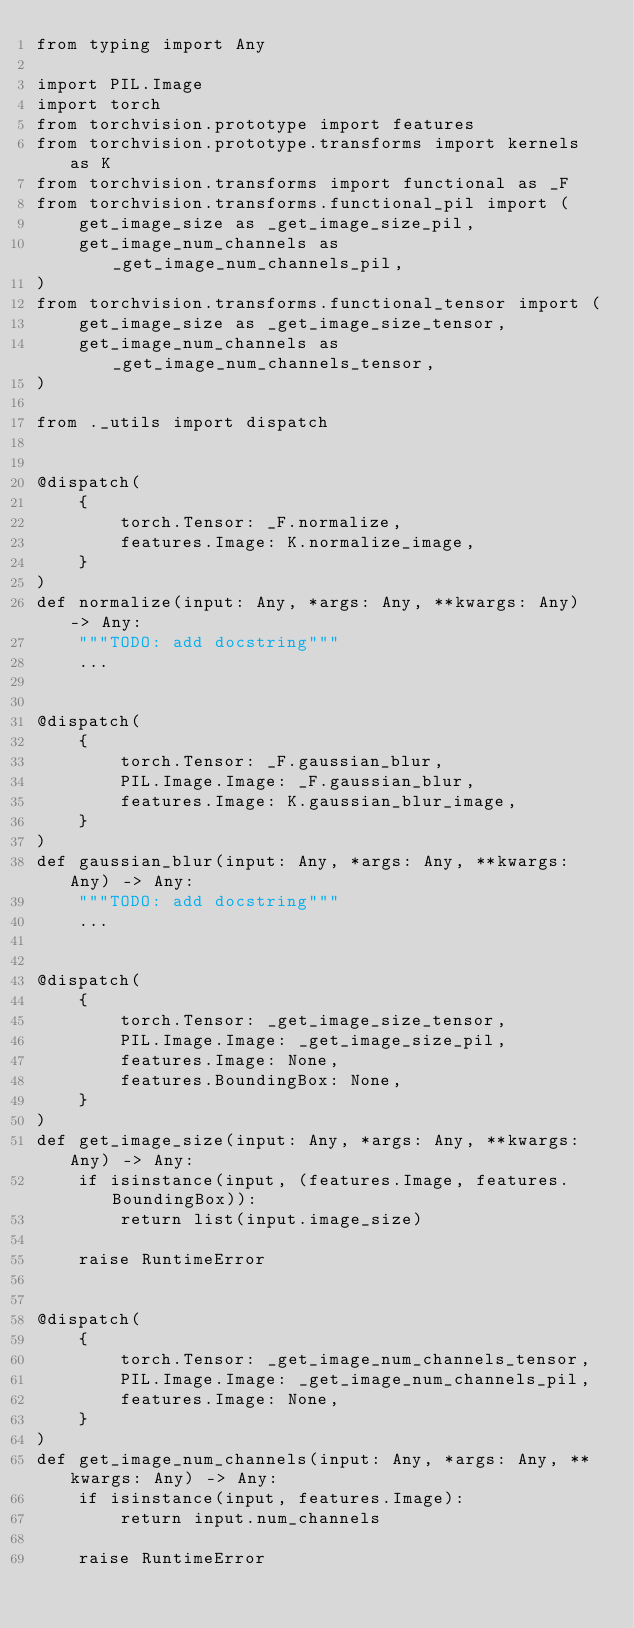Convert code to text. <code><loc_0><loc_0><loc_500><loc_500><_Python_>from typing import Any

import PIL.Image
import torch
from torchvision.prototype import features
from torchvision.prototype.transforms import kernels as K
from torchvision.transforms import functional as _F
from torchvision.transforms.functional_pil import (
    get_image_size as _get_image_size_pil,
    get_image_num_channels as _get_image_num_channels_pil,
)
from torchvision.transforms.functional_tensor import (
    get_image_size as _get_image_size_tensor,
    get_image_num_channels as _get_image_num_channels_tensor,
)

from ._utils import dispatch


@dispatch(
    {
        torch.Tensor: _F.normalize,
        features.Image: K.normalize_image,
    }
)
def normalize(input: Any, *args: Any, **kwargs: Any) -> Any:
    """TODO: add docstring"""
    ...


@dispatch(
    {
        torch.Tensor: _F.gaussian_blur,
        PIL.Image.Image: _F.gaussian_blur,
        features.Image: K.gaussian_blur_image,
    }
)
def gaussian_blur(input: Any, *args: Any, **kwargs: Any) -> Any:
    """TODO: add docstring"""
    ...


@dispatch(
    {
        torch.Tensor: _get_image_size_tensor,
        PIL.Image.Image: _get_image_size_pil,
        features.Image: None,
        features.BoundingBox: None,
    }
)
def get_image_size(input: Any, *args: Any, **kwargs: Any) -> Any:
    if isinstance(input, (features.Image, features.BoundingBox)):
        return list(input.image_size)

    raise RuntimeError


@dispatch(
    {
        torch.Tensor: _get_image_num_channels_tensor,
        PIL.Image.Image: _get_image_num_channels_pil,
        features.Image: None,
    }
)
def get_image_num_channels(input: Any, *args: Any, **kwargs: Any) -> Any:
    if isinstance(input, features.Image):
        return input.num_channels

    raise RuntimeError
</code> 